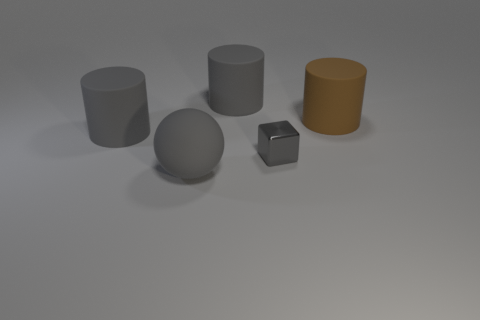Add 2 gray cubes. How many objects exist? 7 Subtract all cylinders. How many objects are left? 2 Add 3 large gray rubber spheres. How many large gray rubber spheres exist? 4 Subtract 0 red cylinders. How many objects are left? 5 Subtract all small brown blocks. Subtract all shiny cubes. How many objects are left? 4 Add 3 small things. How many small things are left? 4 